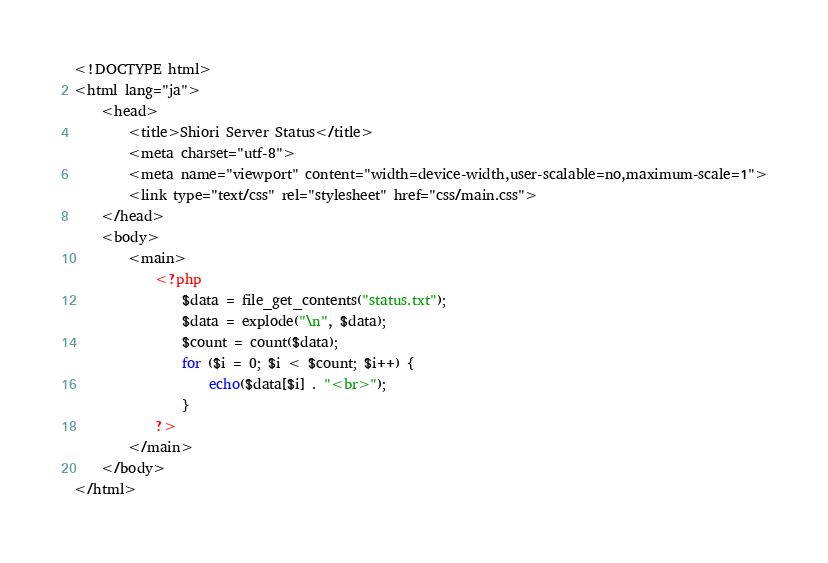<code> <loc_0><loc_0><loc_500><loc_500><_PHP_><!DOCTYPE html>
<html lang="ja">
	<head>
		<title>Shiori Server Status</title>
		<meta charset="utf-8">
		<meta name="viewport" content="width=device-width,user-scalable=no,maximum-scale=1">
		<link type="text/css" rel="stylesheet" href="css/main.css">
	</head>
	<body>
		<main>
			<?php
				$data = file_get_contents("status.txt");
				$data = explode("\n", $data);
				$count = count($data);
				for ($i = 0; $i < $count; $i++) {
					echo($data[$i] . "<br>");
				}
			?>
		</main>
	</body>
</html>
</code> 